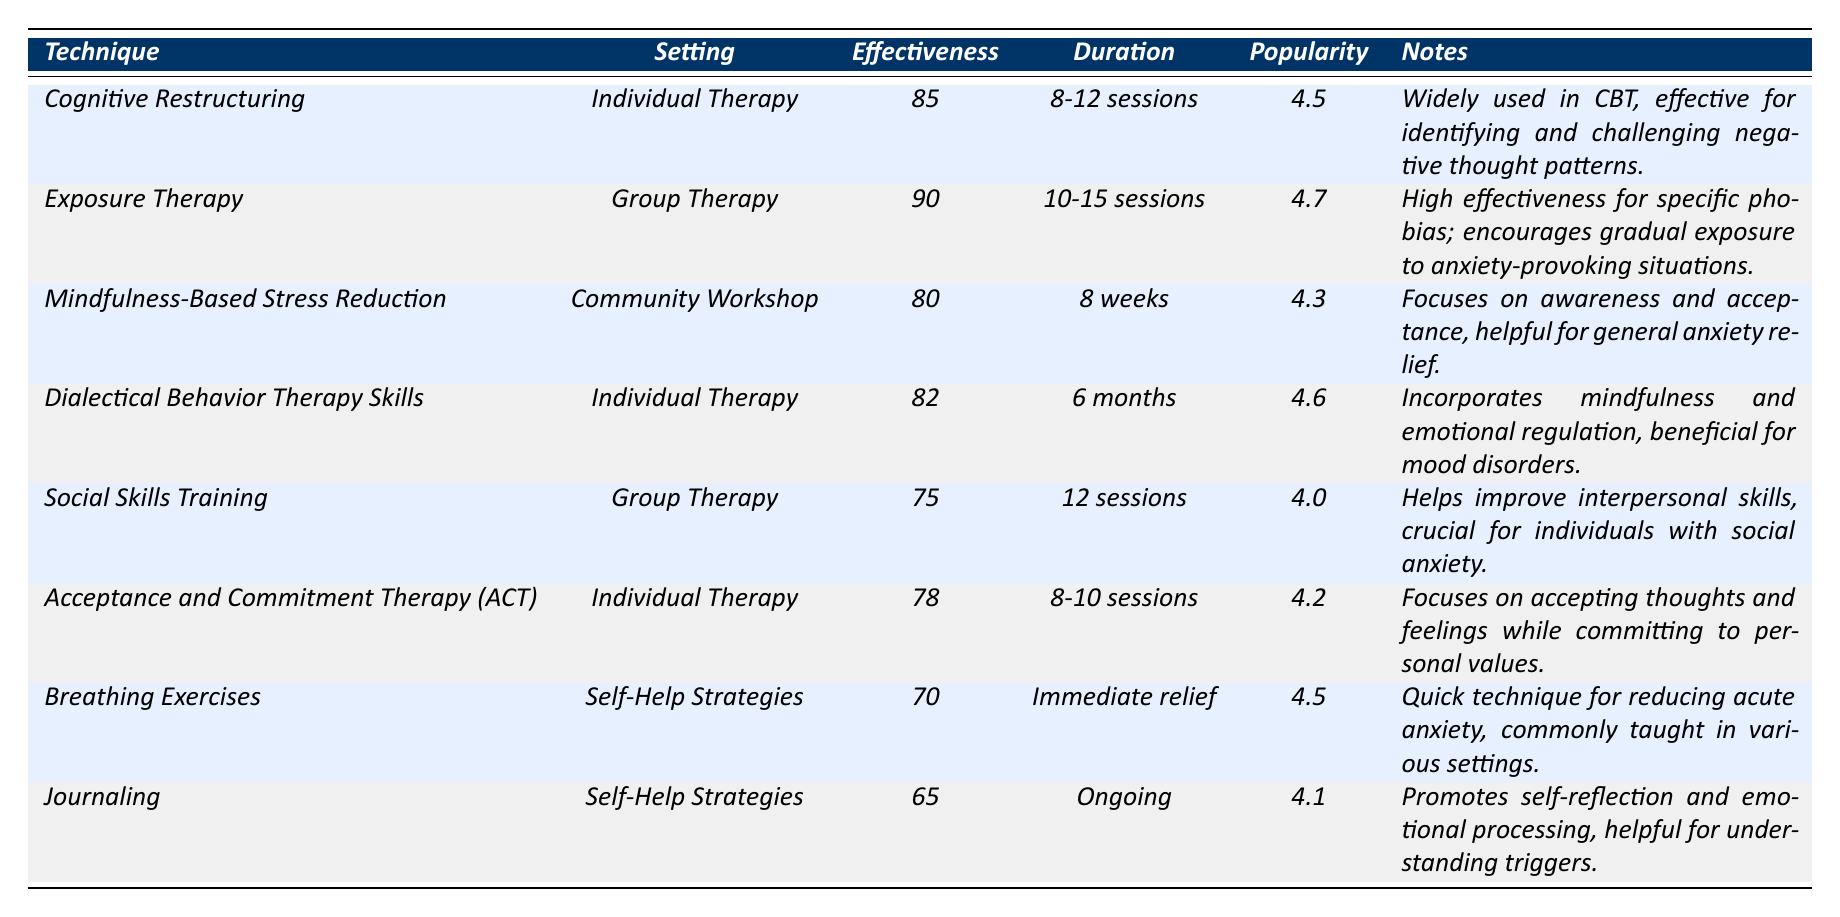What is the effectiveness score of Breathing Exercises? According to the table, Breathing Exercises have an effectiveness score listed as 70.
Answer: 70 Which technique has the highest popularity rating? By examining the table, Exposure Therapy has the highest popularity rating at 4.7.
Answer: Exposure Therapy How many sessions are required for Cognitive Restructuring? The table indicates that Cognitive Restructuring requires 8-12 sessions.
Answer: 8-12 sessions What is the duration for Mindfulness-Based Stress Reduction? The table specifies that Mindfulness-Based Stress Reduction has a duration of 8 weeks.
Answer: 8 weeks Is Acceptance and Commitment Therapy (ACT) more effective than Social Skills Training? The effectiveness score for ACT is 78, while Social Skills Training has a score of 75. Therefore, ACT is more effective.
Answer: Yes What is the average effectiveness score of techniques used in Group Therapy? The techniques listed under Group Therapy are Exposure Therapy (90) and Social Skills Training (75). The average effectiveness is (90 + 75) / 2 = 82.5.
Answer: 82.5 Which technique has the lowest effectiveness score? Looking at the table, Journaling has the lowest effectiveness score at 65.
Answer: Journaling How does the effectiveness score of Dialectical Behavior Therapy Skills compare to Mindfulness-Based Stress Reduction? Dialectical Behavior Therapy Skills have an effectiveness score of 82, which is higher than that of Mindfulness-Based Stress Reduction, which has a score of 80.
Answer: Higher What is the combined popularity rating of techniques used in Individual Therapy? The popularity ratings of techniques used in Individual Therapy are Cognitive Restructuring (4.5), Dialectical Behavior Therapy Skills (4.6), and Acceptance and Commitment Therapy (4.2). The combined popularity rating is 4.5 + 4.6 + 4.2 = 13.3.
Answer: 13.3 What therapeutic setting has the highest effectiveness score among the techniques listed? By reviewing the effectiveness scores in the settings, Exposure Therapy in Group Therapy has the highest score of 90.
Answer: Group Therapy 